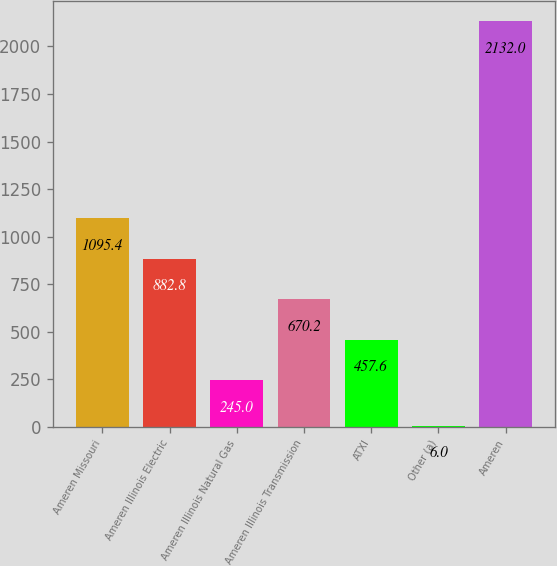Convert chart. <chart><loc_0><loc_0><loc_500><loc_500><bar_chart><fcel>Ameren Missouri<fcel>Ameren Illinois Electric<fcel>Ameren Illinois Natural Gas<fcel>Ameren Illinois Transmission<fcel>ATXI<fcel>Other (a)<fcel>Ameren<nl><fcel>1095.4<fcel>882.8<fcel>245<fcel>670.2<fcel>457.6<fcel>6<fcel>2132<nl></chart> 